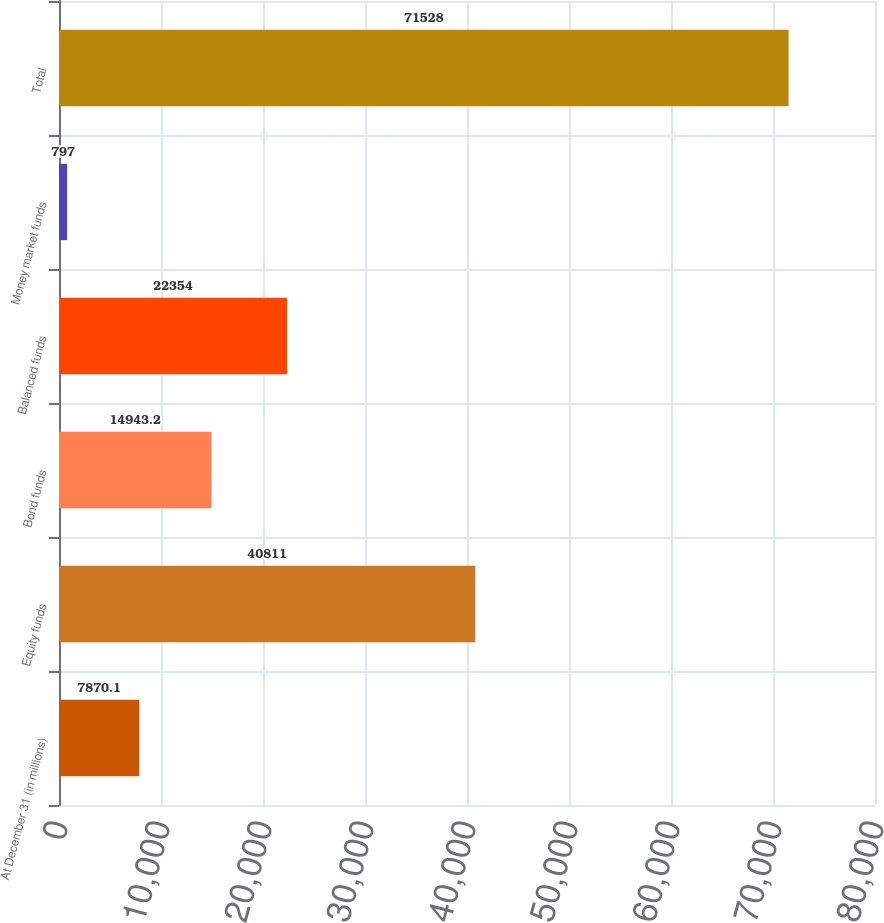<chart> <loc_0><loc_0><loc_500><loc_500><bar_chart><fcel>At December 31 (in millions)<fcel>Equity funds<fcel>Bond funds<fcel>Balanced funds<fcel>Money market funds<fcel>Total<nl><fcel>7870.1<fcel>40811<fcel>14943.2<fcel>22354<fcel>797<fcel>71528<nl></chart> 